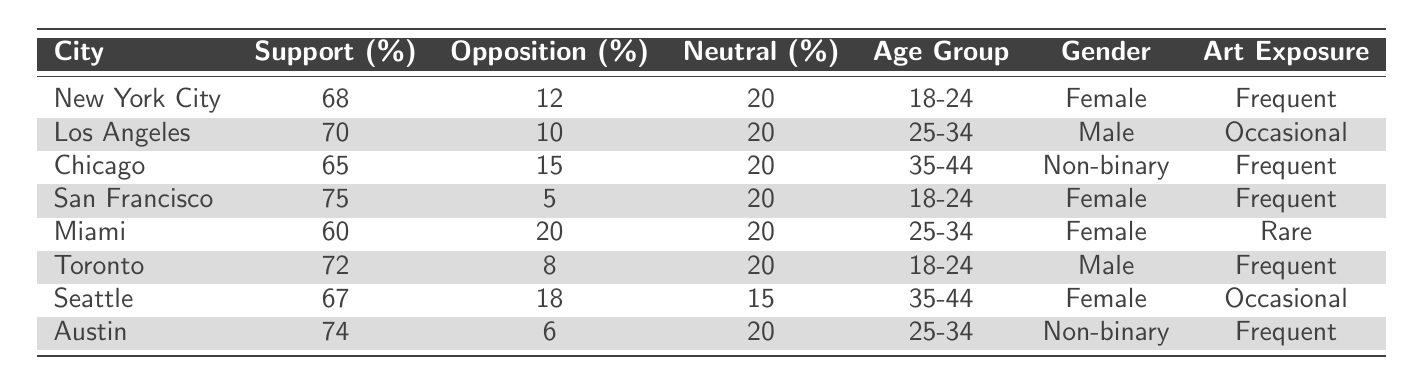What city has the highest percentage of support for feminist art? By checking the support percentages for each city, San Francisco has the highest value at 75%.
Answer: San Francisco What is the percentage of opposition to feminist art in Toronto? Referring to the table, Toronto has an opposition percentage of 8%.
Answer: 8% Which age group has the most participants in the survey? The age groups presented are 18-24, 25-34, and 35-44. Each is represented, but there are multiple entries for 18-24 and 25-34. However, there is no specific count in the table, so we can't determine which is greatest.
Answer: Cannot be determined What is the average support percentage for feminist art across all cities? Totaling the support percentages (68 + 70 + 65 + 75 + 60 + 72 + 67 + 74 = 591), then dividing by the number of cities (8), gives an average of 591/8 = 73.875.
Answer: 73.875 Is there a city where the opposition percentage is 20%? By looking at the table, Miami shows an opposition percentage of 20%. Therefore, the answer is yes.
Answer: Yes What is the difference between the highest and lowest percentages of support for feminist art? The highest support percentage is 75% (San Francisco) and the lowest is 60% (Miami). The difference is 75% - 60% = 15%.
Answer: 15% How many cities had a neutral percentage of 20%? In the table, every city lists a neutral percentage of 20%. This indicates that there are 8 cities total.
Answer: 8 Which city has the lowest support for feminist art and what is the percentage? The city with the lowest support percentage is Miami at 60%.
Answer: Miami, 60% In which city does the non-binary gender group show the highest support for feminist art? Looking at the table, Austin shows the highest support at 74% among non-binary participants.
Answer: Austin Do all cities list frequent exposure to art events? Examining the table shows that Miami has "Rare" exposure and Los Angeles as "Occasional," thus not all cities list frequent exposure to art events.
Answer: No Which age group has the highest support percentage for feminist art? Comparing the support percentages across all age groups: 18-24 (68% NYC, 75% SF, 72% Toronto), 25-34 (70% LA, 60% Miami, 74% Austin), and 35-44 (65% Chicago, 67% Seattle), the highest support percentage is amongst the 18-24 age group with a maximum of 75% from San Francisco.
Answer: 18-24 age group 